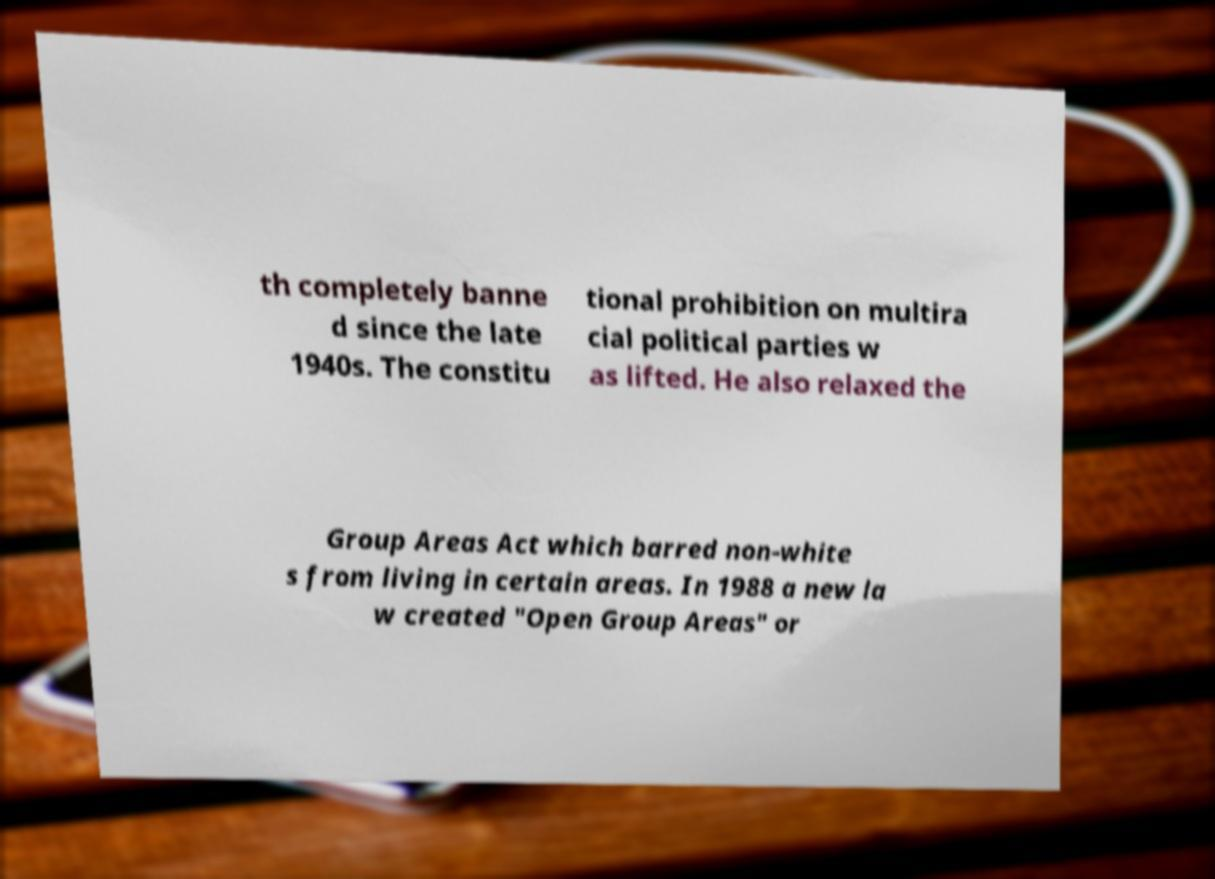Could you extract and type out the text from this image? th completely banne d since the late 1940s. The constitu tional prohibition on multira cial political parties w as lifted. He also relaxed the Group Areas Act which barred non-white s from living in certain areas. In 1988 a new la w created "Open Group Areas" or 